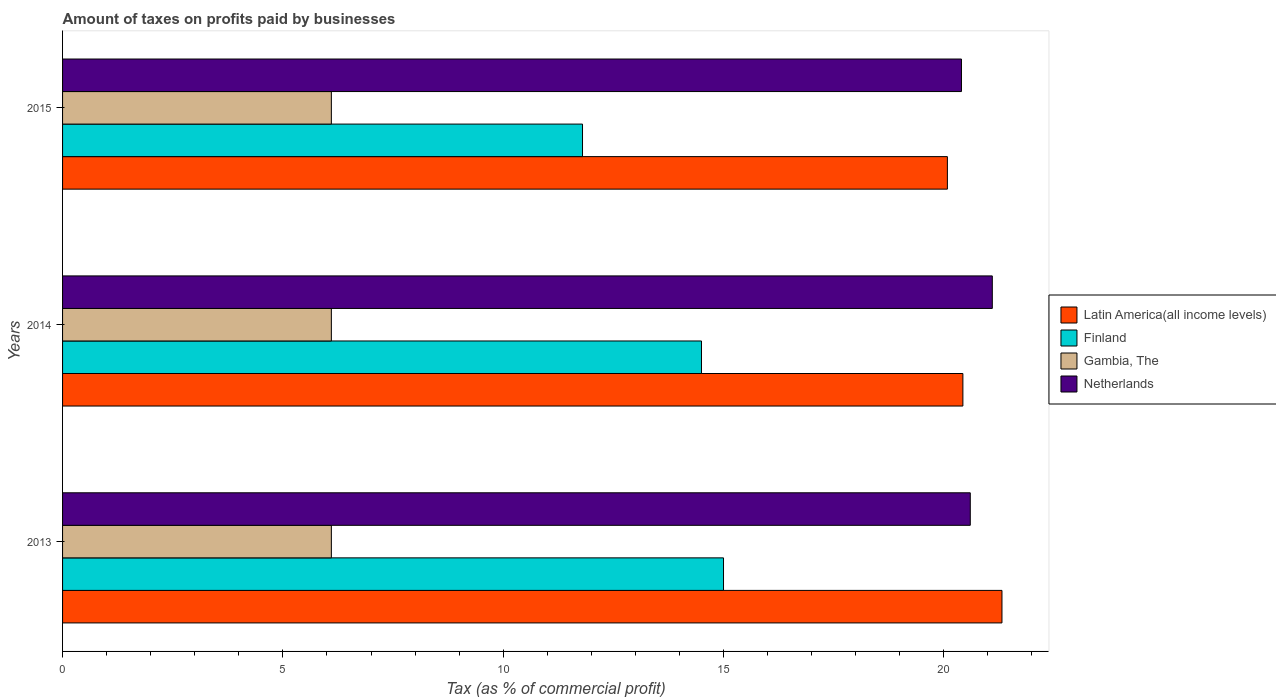How many groups of bars are there?
Your response must be concise. 3. Are the number of bars on each tick of the Y-axis equal?
Offer a very short reply. Yes. How many bars are there on the 2nd tick from the bottom?
Ensure brevity in your answer.  4. In how many cases, is the number of bars for a given year not equal to the number of legend labels?
Keep it short and to the point. 0. What is the percentage of taxes paid by businesses in Finland in 2015?
Make the answer very short. 11.8. Across all years, what is the maximum percentage of taxes paid by businesses in Gambia, The?
Offer a terse response. 6.1. In which year was the percentage of taxes paid by businesses in Finland maximum?
Offer a terse response. 2013. In which year was the percentage of taxes paid by businesses in Netherlands minimum?
Offer a terse response. 2015. What is the total percentage of taxes paid by businesses in Netherlands in the graph?
Offer a terse response. 62.1. What is the difference between the percentage of taxes paid by businesses in Latin America(all income levels) in 2013 and that in 2015?
Give a very brief answer. 1.24. What is the difference between the percentage of taxes paid by businesses in Finland in 2014 and the percentage of taxes paid by businesses in Netherlands in 2013?
Your response must be concise. -6.1. What is the average percentage of taxes paid by businesses in Gambia, The per year?
Make the answer very short. 6.1. In the year 2015, what is the difference between the percentage of taxes paid by businesses in Latin America(all income levels) and percentage of taxes paid by businesses in Netherlands?
Offer a terse response. -0.32. What is the ratio of the percentage of taxes paid by businesses in Netherlands in 2013 to that in 2014?
Make the answer very short. 0.98. Is the percentage of taxes paid by businesses in Finland in 2014 less than that in 2015?
Give a very brief answer. No. Is the difference between the percentage of taxes paid by businesses in Latin America(all income levels) in 2013 and 2014 greater than the difference between the percentage of taxes paid by businesses in Netherlands in 2013 and 2014?
Your answer should be very brief. Yes. What is the difference between the highest and the lowest percentage of taxes paid by businesses in Finland?
Keep it short and to the point. 3.2. Is the sum of the percentage of taxes paid by businesses in Latin America(all income levels) in 2014 and 2015 greater than the maximum percentage of taxes paid by businesses in Finland across all years?
Keep it short and to the point. Yes. Is it the case that in every year, the sum of the percentage of taxes paid by businesses in Finland and percentage of taxes paid by businesses in Gambia, The is greater than the sum of percentage of taxes paid by businesses in Latin America(all income levels) and percentage of taxes paid by businesses in Netherlands?
Your response must be concise. No. What does the 3rd bar from the top in 2013 represents?
Provide a short and direct response. Finland. Is it the case that in every year, the sum of the percentage of taxes paid by businesses in Netherlands and percentage of taxes paid by businesses in Gambia, The is greater than the percentage of taxes paid by businesses in Finland?
Your answer should be compact. Yes. What is the difference between two consecutive major ticks on the X-axis?
Your answer should be very brief. 5. Does the graph contain grids?
Ensure brevity in your answer.  No. What is the title of the graph?
Offer a terse response. Amount of taxes on profits paid by businesses. What is the label or title of the X-axis?
Your answer should be very brief. Tax (as % of commercial profit). What is the label or title of the Y-axis?
Provide a short and direct response. Years. What is the Tax (as % of commercial profit) in Latin America(all income levels) in 2013?
Offer a very short reply. 21.32. What is the Tax (as % of commercial profit) in Gambia, The in 2013?
Your response must be concise. 6.1. What is the Tax (as % of commercial profit) of Netherlands in 2013?
Provide a succinct answer. 20.6. What is the Tax (as % of commercial profit) in Latin America(all income levels) in 2014?
Provide a short and direct response. 20.43. What is the Tax (as % of commercial profit) of Finland in 2014?
Your response must be concise. 14.5. What is the Tax (as % of commercial profit) in Gambia, The in 2014?
Your answer should be very brief. 6.1. What is the Tax (as % of commercial profit) of Netherlands in 2014?
Give a very brief answer. 21.1. What is the Tax (as % of commercial profit) in Latin America(all income levels) in 2015?
Your answer should be compact. 20.08. What is the Tax (as % of commercial profit) in Finland in 2015?
Your response must be concise. 11.8. What is the Tax (as % of commercial profit) of Netherlands in 2015?
Provide a succinct answer. 20.4. Across all years, what is the maximum Tax (as % of commercial profit) in Latin America(all income levels)?
Your answer should be very brief. 21.32. Across all years, what is the maximum Tax (as % of commercial profit) of Gambia, The?
Make the answer very short. 6.1. Across all years, what is the maximum Tax (as % of commercial profit) of Netherlands?
Make the answer very short. 21.1. Across all years, what is the minimum Tax (as % of commercial profit) of Latin America(all income levels)?
Provide a short and direct response. 20.08. Across all years, what is the minimum Tax (as % of commercial profit) of Finland?
Ensure brevity in your answer.  11.8. Across all years, what is the minimum Tax (as % of commercial profit) in Gambia, The?
Keep it short and to the point. 6.1. Across all years, what is the minimum Tax (as % of commercial profit) in Netherlands?
Provide a succinct answer. 20.4. What is the total Tax (as % of commercial profit) of Latin America(all income levels) in the graph?
Ensure brevity in your answer.  61.83. What is the total Tax (as % of commercial profit) in Finland in the graph?
Keep it short and to the point. 41.3. What is the total Tax (as % of commercial profit) of Netherlands in the graph?
Provide a succinct answer. 62.1. What is the difference between the Tax (as % of commercial profit) of Latin America(all income levels) in 2013 and that in 2014?
Your answer should be compact. 0.89. What is the difference between the Tax (as % of commercial profit) in Gambia, The in 2013 and that in 2014?
Offer a very short reply. 0. What is the difference between the Tax (as % of commercial profit) in Netherlands in 2013 and that in 2014?
Keep it short and to the point. -0.5. What is the difference between the Tax (as % of commercial profit) in Latin America(all income levels) in 2013 and that in 2015?
Make the answer very short. 1.24. What is the difference between the Tax (as % of commercial profit) in Netherlands in 2013 and that in 2015?
Make the answer very short. 0.2. What is the difference between the Tax (as % of commercial profit) in Latin America(all income levels) in 2014 and that in 2015?
Your answer should be compact. 0.35. What is the difference between the Tax (as % of commercial profit) in Finland in 2014 and that in 2015?
Offer a terse response. 2.7. What is the difference between the Tax (as % of commercial profit) of Latin America(all income levels) in 2013 and the Tax (as % of commercial profit) of Finland in 2014?
Offer a very short reply. 6.82. What is the difference between the Tax (as % of commercial profit) in Latin America(all income levels) in 2013 and the Tax (as % of commercial profit) in Gambia, The in 2014?
Provide a short and direct response. 15.22. What is the difference between the Tax (as % of commercial profit) in Latin America(all income levels) in 2013 and the Tax (as % of commercial profit) in Netherlands in 2014?
Provide a succinct answer. 0.22. What is the difference between the Tax (as % of commercial profit) in Finland in 2013 and the Tax (as % of commercial profit) in Netherlands in 2014?
Ensure brevity in your answer.  -6.1. What is the difference between the Tax (as % of commercial profit) of Latin America(all income levels) in 2013 and the Tax (as % of commercial profit) of Finland in 2015?
Make the answer very short. 9.52. What is the difference between the Tax (as % of commercial profit) in Latin America(all income levels) in 2013 and the Tax (as % of commercial profit) in Gambia, The in 2015?
Provide a succinct answer. 15.22. What is the difference between the Tax (as % of commercial profit) in Latin America(all income levels) in 2013 and the Tax (as % of commercial profit) in Netherlands in 2015?
Your answer should be compact. 0.92. What is the difference between the Tax (as % of commercial profit) of Finland in 2013 and the Tax (as % of commercial profit) of Gambia, The in 2015?
Give a very brief answer. 8.9. What is the difference between the Tax (as % of commercial profit) in Gambia, The in 2013 and the Tax (as % of commercial profit) in Netherlands in 2015?
Ensure brevity in your answer.  -14.3. What is the difference between the Tax (as % of commercial profit) in Latin America(all income levels) in 2014 and the Tax (as % of commercial profit) in Finland in 2015?
Keep it short and to the point. 8.63. What is the difference between the Tax (as % of commercial profit) in Latin America(all income levels) in 2014 and the Tax (as % of commercial profit) in Gambia, The in 2015?
Provide a succinct answer. 14.33. What is the difference between the Tax (as % of commercial profit) of Latin America(all income levels) in 2014 and the Tax (as % of commercial profit) of Netherlands in 2015?
Provide a short and direct response. 0.03. What is the difference between the Tax (as % of commercial profit) of Finland in 2014 and the Tax (as % of commercial profit) of Gambia, The in 2015?
Your response must be concise. 8.4. What is the difference between the Tax (as % of commercial profit) in Finland in 2014 and the Tax (as % of commercial profit) in Netherlands in 2015?
Make the answer very short. -5.9. What is the difference between the Tax (as % of commercial profit) in Gambia, The in 2014 and the Tax (as % of commercial profit) in Netherlands in 2015?
Give a very brief answer. -14.3. What is the average Tax (as % of commercial profit) in Latin America(all income levels) per year?
Your answer should be very brief. 20.61. What is the average Tax (as % of commercial profit) of Finland per year?
Your response must be concise. 13.77. What is the average Tax (as % of commercial profit) of Gambia, The per year?
Your answer should be compact. 6.1. What is the average Tax (as % of commercial profit) of Netherlands per year?
Ensure brevity in your answer.  20.7. In the year 2013, what is the difference between the Tax (as % of commercial profit) of Latin America(all income levels) and Tax (as % of commercial profit) of Finland?
Keep it short and to the point. 6.32. In the year 2013, what is the difference between the Tax (as % of commercial profit) in Latin America(all income levels) and Tax (as % of commercial profit) in Gambia, The?
Keep it short and to the point. 15.22. In the year 2013, what is the difference between the Tax (as % of commercial profit) in Latin America(all income levels) and Tax (as % of commercial profit) in Netherlands?
Provide a short and direct response. 0.72. In the year 2013, what is the difference between the Tax (as % of commercial profit) in Finland and Tax (as % of commercial profit) in Netherlands?
Make the answer very short. -5.6. In the year 2013, what is the difference between the Tax (as % of commercial profit) of Gambia, The and Tax (as % of commercial profit) of Netherlands?
Offer a very short reply. -14.5. In the year 2014, what is the difference between the Tax (as % of commercial profit) in Latin America(all income levels) and Tax (as % of commercial profit) in Finland?
Make the answer very short. 5.93. In the year 2014, what is the difference between the Tax (as % of commercial profit) of Latin America(all income levels) and Tax (as % of commercial profit) of Gambia, The?
Your answer should be compact. 14.33. In the year 2014, what is the difference between the Tax (as % of commercial profit) of Latin America(all income levels) and Tax (as % of commercial profit) of Netherlands?
Keep it short and to the point. -0.67. In the year 2014, what is the difference between the Tax (as % of commercial profit) in Finland and Tax (as % of commercial profit) in Netherlands?
Ensure brevity in your answer.  -6.6. In the year 2014, what is the difference between the Tax (as % of commercial profit) in Gambia, The and Tax (as % of commercial profit) in Netherlands?
Ensure brevity in your answer.  -15. In the year 2015, what is the difference between the Tax (as % of commercial profit) of Latin America(all income levels) and Tax (as % of commercial profit) of Finland?
Give a very brief answer. 8.28. In the year 2015, what is the difference between the Tax (as % of commercial profit) of Latin America(all income levels) and Tax (as % of commercial profit) of Gambia, The?
Offer a terse response. 13.98. In the year 2015, what is the difference between the Tax (as % of commercial profit) of Latin America(all income levels) and Tax (as % of commercial profit) of Netherlands?
Ensure brevity in your answer.  -0.32. In the year 2015, what is the difference between the Tax (as % of commercial profit) in Finland and Tax (as % of commercial profit) in Gambia, The?
Your response must be concise. 5.7. In the year 2015, what is the difference between the Tax (as % of commercial profit) of Gambia, The and Tax (as % of commercial profit) of Netherlands?
Offer a terse response. -14.3. What is the ratio of the Tax (as % of commercial profit) of Latin America(all income levels) in 2013 to that in 2014?
Offer a terse response. 1.04. What is the ratio of the Tax (as % of commercial profit) in Finland in 2013 to that in 2014?
Ensure brevity in your answer.  1.03. What is the ratio of the Tax (as % of commercial profit) of Gambia, The in 2013 to that in 2014?
Offer a terse response. 1. What is the ratio of the Tax (as % of commercial profit) in Netherlands in 2013 to that in 2014?
Keep it short and to the point. 0.98. What is the ratio of the Tax (as % of commercial profit) of Latin America(all income levels) in 2013 to that in 2015?
Offer a terse response. 1.06. What is the ratio of the Tax (as % of commercial profit) in Finland in 2013 to that in 2015?
Your answer should be compact. 1.27. What is the ratio of the Tax (as % of commercial profit) of Gambia, The in 2013 to that in 2015?
Give a very brief answer. 1. What is the ratio of the Tax (as % of commercial profit) of Netherlands in 2013 to that in 2015?
Keep it short and to the point. 1.01. What is the ratio of the Tax (as % of commercial profit) in Latin America(all income levels) in 2014 to that in 2015?
Provide a short and direct response. 1.02. What is the ratio of the Tax (as % of commercial profit) in Finland in 2014 to that in 2015?
Ensure brevity in your answer.  1.23. What is the ratio of the Tax (as % of commercial profit) of Gambia, The in 2014 to that in 2015?
Your answer should be compact. 1. What is the ratio of the Tax (as % of commercial profit) in Netherlands in 2014 to that in 2015?
Offer a very short reply. 1.03. What is the difference between the highest and the second highest Tax (as % of commercial profit) in Latin America(all income levels)?
Your response must be concise. 0.89. What is the difference between the highest and the second highest Tax (as % of commercial profit) of Finland?
Your response must be concise. 0.5. What is the difference between the highest and the lowest Tax (as % of commercial profit) in Latin America(all income levels)?
Offer a terse response. 1.24. What is the difference between the highest and the lowest Tax (as % of commercial profit) of Finland?
Keep it short and to the point. 3.2. What is the difference between the highest and the lowest Tax (as % of commercial profit) in Gambia, The?
Make the answer very short. 0. What is the difference between the highest and the lowest Tax (as % of commercial profit) in Netherlands?
Provide a succinct answer. 0.7. 